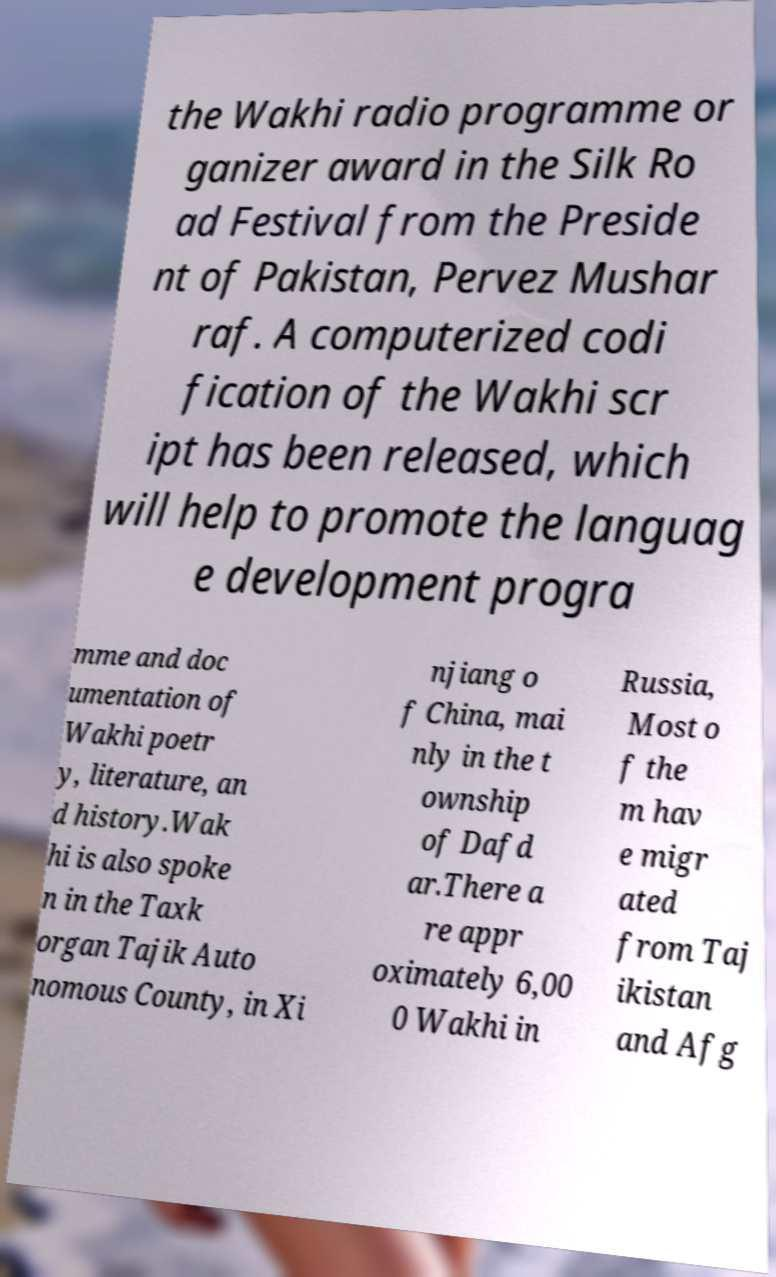For documentation purposes, I need the text within this image transcribed. Could you provide that? the Wakhi radio programme or ganizer award in the Silk Ro ad Festival from the Preside nt of Pakistan, Pervez Mushar raf. A computerized codi fication of the Wakhi scr ipt has been released, which will help to promote the languag e development progra mme and doc umentation of Wakhi poetr y, literature, an d history.Wak hi is also spoke n in the Taxk organ Tajik Auto nomous County, in Xi njiang o f China, mai nly in the t ownship of Dafd ar.There a re appr oximately 6,00 0 Wakhi in Russia, Most o f the m hav e migr ated from Taj ikistan and Afg 